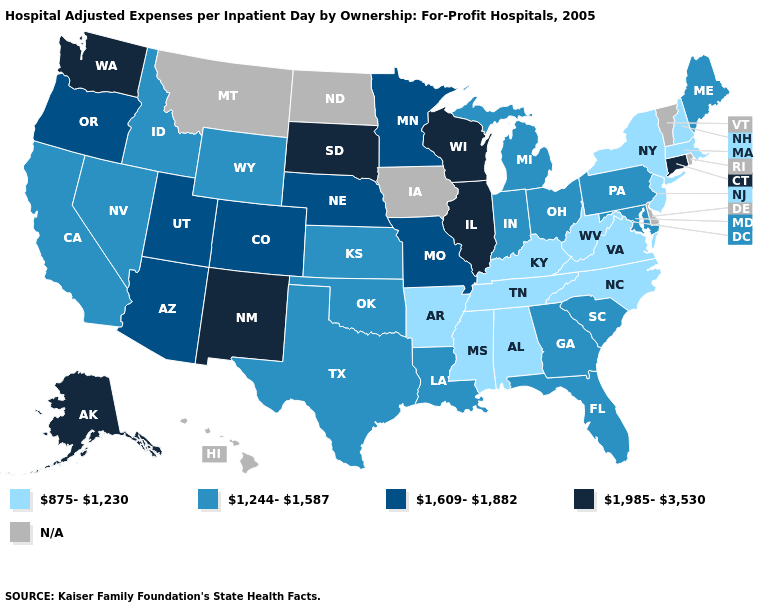What is the highest value in the MidWest ?
Concise answer only. 1,985-3,530. Among the states that border South Dakota , which have the lowest value?
Concise answer only. Wyoming. Name the states that have a value in the range 1,609-1,882?
Answer briefly. Arizona, Colorado, Minnesota, Missouri, Nebraska, Oregon, Utah. Is the legend a continuous bar?
Be succinct. No. What is the highest value in states that border Wyoming?
Keep it brief. 1,985-3,530. What is the lowest value in the USA?
Keep it brief. 875-1,230. What is the value of New Hampshire?
Short answer required. 875-1,230. What is the value of Hawaii?
Write a very short answer. N/A. Name the states that have a value in the range 1,609-1,882?
Give a very brief answer. Arizona, Colorado, Minnesota, Missouri, Nebraska, Oregon, Utah. How many symbols are there in the legend?
Write a very short answer. 5. What is the value of Missouri?
Write a very short answer. 1,609-1,882. What is the value of Michigan?
Be succinct. 1,244-1,587. Does Virginia have the highest value in the USA?
Short answer required. No. Does New Hampshire have the lowest value in the Northeast?
Concise answer only. Yes. What is the highest value in states that border Idaho?
Short answer required. 1,985-3,530. 